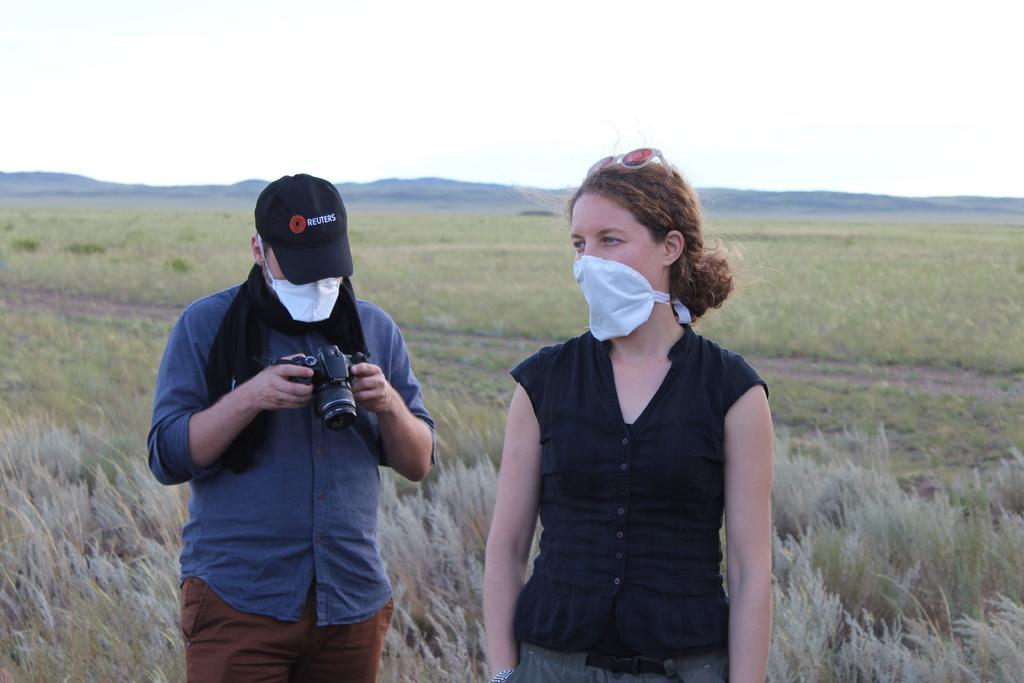How many people are present in the image? There are two persons standing in the image. What is one of the persons holding in the image? There is a person holding a camera in the image. What type of natural environment can be seen in the background of the image? There is grass, hills, and the sky visible in the background of the image. Can you see a ghost in the image? There is no ghost present in the image. What type of knot is being tied by one of the persons in the image? There is no knot-tying activity depicted in the image. 